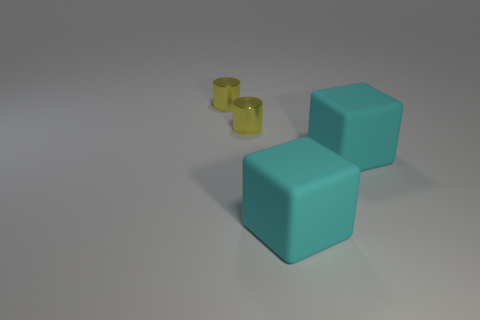Is the number of small metallic cylinders less than the number of objects?
Your response must be concise. Yes. How many objects are yellow metal cylinders or cyan matte things?
Your answer should be compact. 4. What number of cylinders are large objects or tiny yellow things?
Your answer should be compact. 2. Are any tiny purple shiny things visible?
Provide a succinct answer. No. What number of cyan things are large cubes or metallic things?
Ensure brevity in your answer.  2. What number of large objects are either cyan matte objects or yellow metal cylinders?
Your answer should be very brief. 2. What number of small objects are there?
Provide a short and direct response. 2. How many rubber objects are blocks or tiny yellow objects?
Your response must be concise. 2. Is the number of things greater than the number of rubber cubes?
Keep it short and to the point. Yes. 